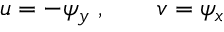Convert formula to latex. <formula><loc_0><loc_0><loc_500><loc_500>u = - \psi _ { y } \, , \quad v = \psi _ { x }</formula> 